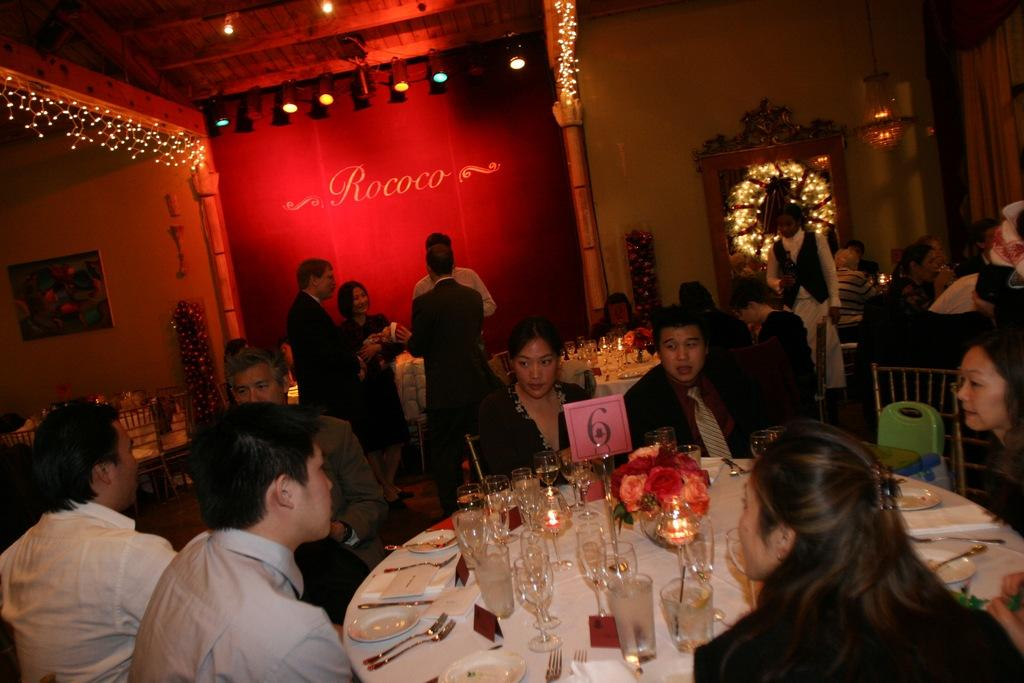What are the people in the image doing? There are people sitting on chairs and standing in the image. What objects are on the table in the image? Wine glasses, plates, and spoons are on the table in the image. What additional feature can be seen in the image? Decorative lights are visible in the image. What type of beast is being controlled by the people in the image? There is no beast present in the image; it features people sitting on chairs, standing, and objects on a table. 